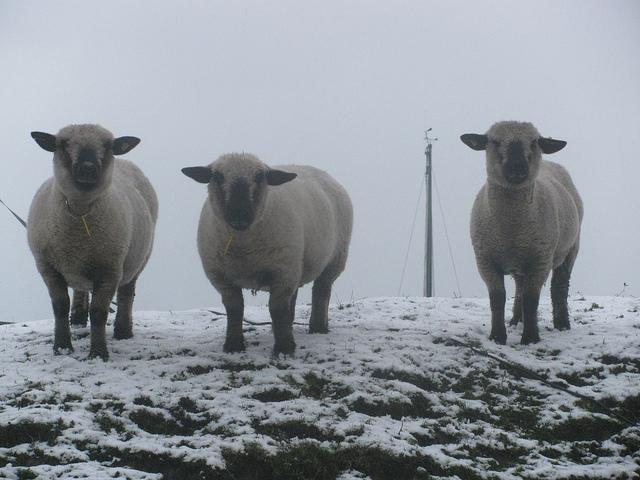How many sheep are there?
Give a very brief answer. 3. How many sheep are in the picture?
Give a very brief answer. 3. How many people are on the beach?
Give a very brief answer. 0. 